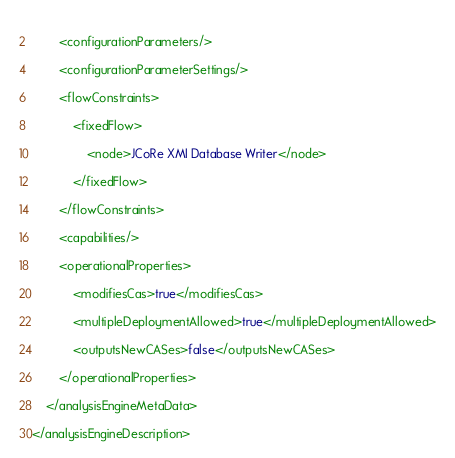<code> <loc_0><loc_0><loc_500><loc_500><_XML_>                
        <configurationParameters/>
                
        <configurationParameterSettings/>
                
        <flowConstraints>
                        
            <fixedFlow>
                                
                <node>JCoRe XMI Database Writer</node>
                            
            </fixedFlow>
                    
        </flowConstraints>
                
        <capabilities/>
                
        <operationalProperties>
                        
            <modifiesCas>true</modifiesCas>
                        
            <multipleDeploymentAllowed>true</multipleDeploymentAllowed>
                        
            <outputsNewCASes>false</outputsNewCASes>
                    
        </operationalProperties>
            
    </analysisEngineMetaData>
    
</analysisEngineDescription>
</code> 